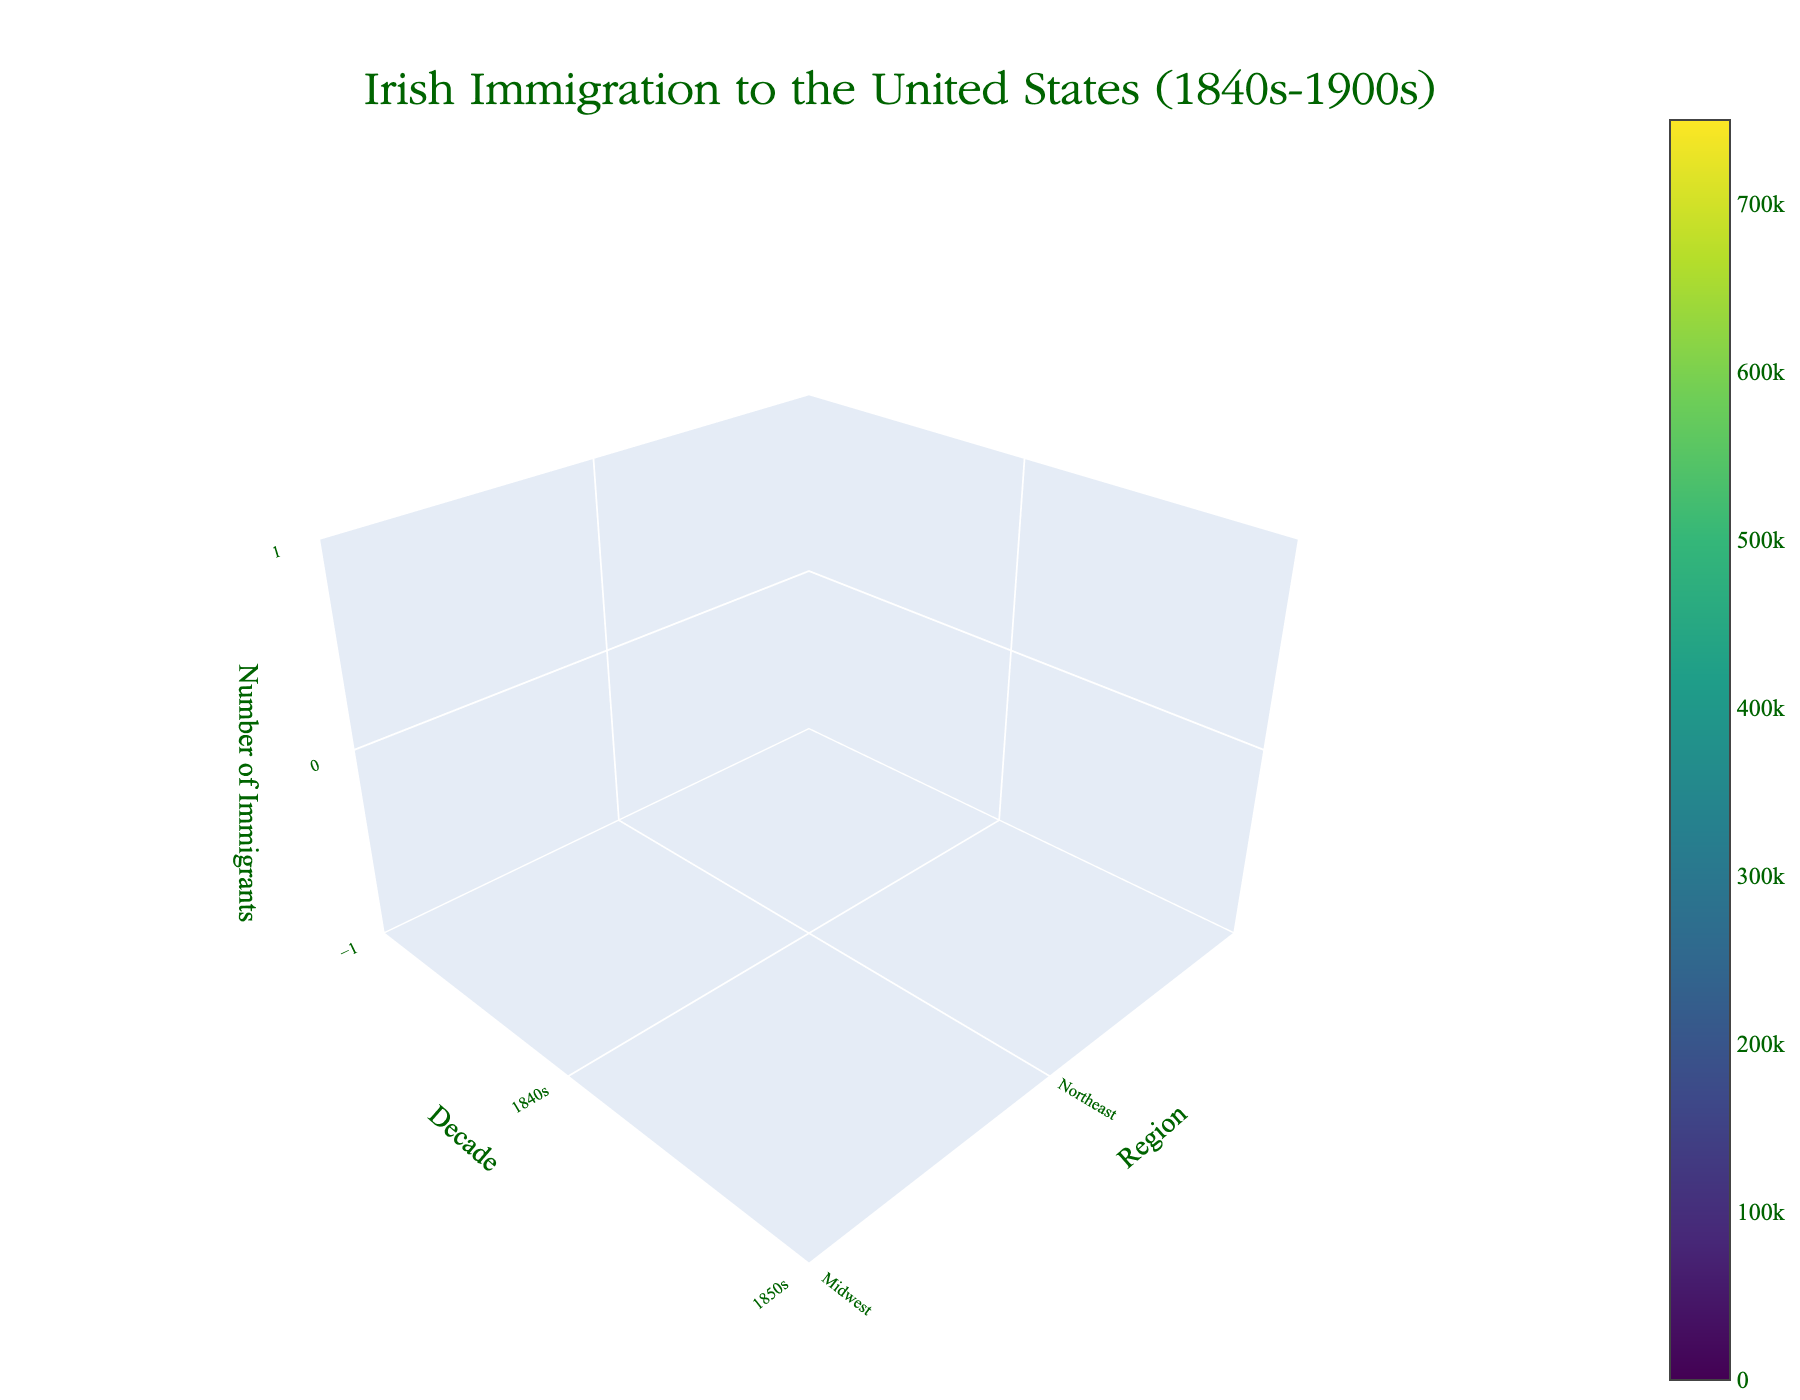How many regions are displayed in the figure? The figure lists the regions in the x-axis, so we can count the unique regions shown. They are: Northeast, Midwest, South, and West.
Answer: 4 Which decade shows the highest number of Irish immigrants in the Northeast? By inspecting the z-axis values across the decades for the Northeast region, the highest point appears in the 1850s.
Answer: 1850s Which region had the smallest number of Irish immigrants in the 1840s? By comparing the z-axis height for each region in the 1840s, the West has the smallest number of immigrants at 10,000.
Answer: West What is the overall trend of Irish immigration to the Midwest from the 1840s to the 1900s? By examining the y-axis (decade) and the corresponding z-axis values for the Midwest, it's visible that the number of immigrants peaked in the 1850s and then gradually declined.
Answer: Peaked in the 1850s, then declined How does the amount of immigrants in the 1900s compare between the Northeast and the South? Looking at the 1900s on the y-axis and comparing the heights of the z-axis for the Northeast (150,000) and the South (25,000), the Northeast has significantly more immigrants.
Answer: The Northeast has more What's the total number of Irish immigrants to the West in the entire period shown? By summing the z-axis values for the West across all decades (10,000 + 50,000 + 75,000 + 100,000 + 110,000 + 120,000 + 100,000), we get 565,000.
Answer: 565,000 Identify the decade with the highest total immigration across all regions. Add the immigrants in each region per decade and compare: 1840s (710,000), 1850s (1,250,000), 1860s (800,000), 1870s (650,000), 1880s (550,000), 1890s (450,000), 1900s (350,000). The 1850s have the highest total immigration.
Answer: 1850s In which region did the number of Irish immigrants increase in every subsequent decade, if any? Analyzing each region across decades shows that none of the regions had a continuous increase in immigrants in every subsequent decade. Thus, the answer is none.
Answer: None Compare the number of immigrants to the Midwest in the 1860s versus the 1870s. From the plot, for the Midwest, the value in the 1860s is 250,000 and in the 1870s is 200,000.
Answer: 250,000 vs 200,000 What's the visual pattern of the West region’s Irish immigrant data? The volume plot shows the West's immigrant numbers start low, increase in the mid-period (peak at 120,000 in the 1890s), then slightly drop in the 1900s.
Answer: Start low, peak in the 1890s, then drop 